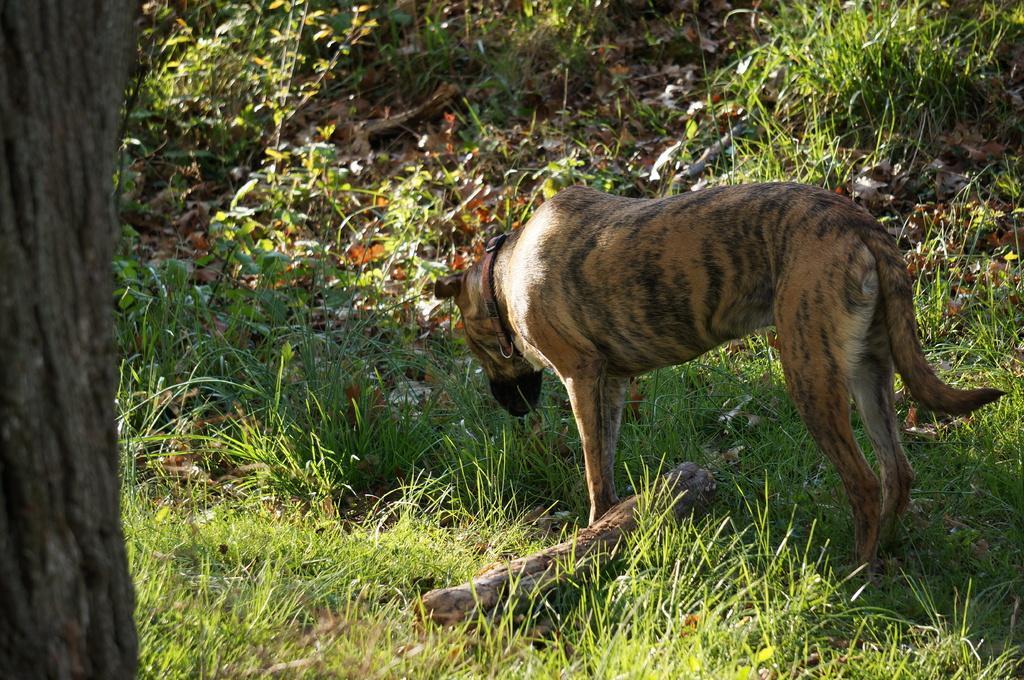Could you give a brief overview of what you see in this image? In this picture I can see a dog in front and it is on the grass. On the left side of this picture I can see the trunk of a tree. In the background I can see the grass and the leaves. 